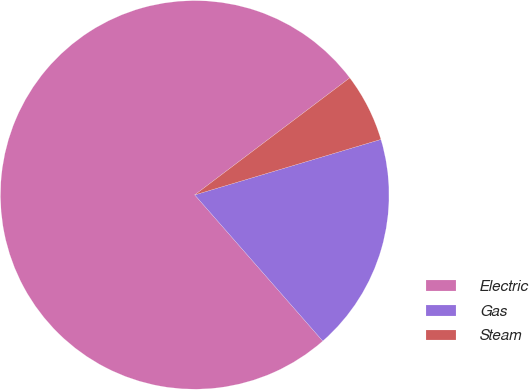Convert chart. <chart><loc_0><loc_0><loc_500><loc_500><pie_chart><fcel>Electric<fcel>Gas<fcel>Steam<nl><fcel>76.16%<fcel>18.16%<fcel>5.68%<nl></chart> 